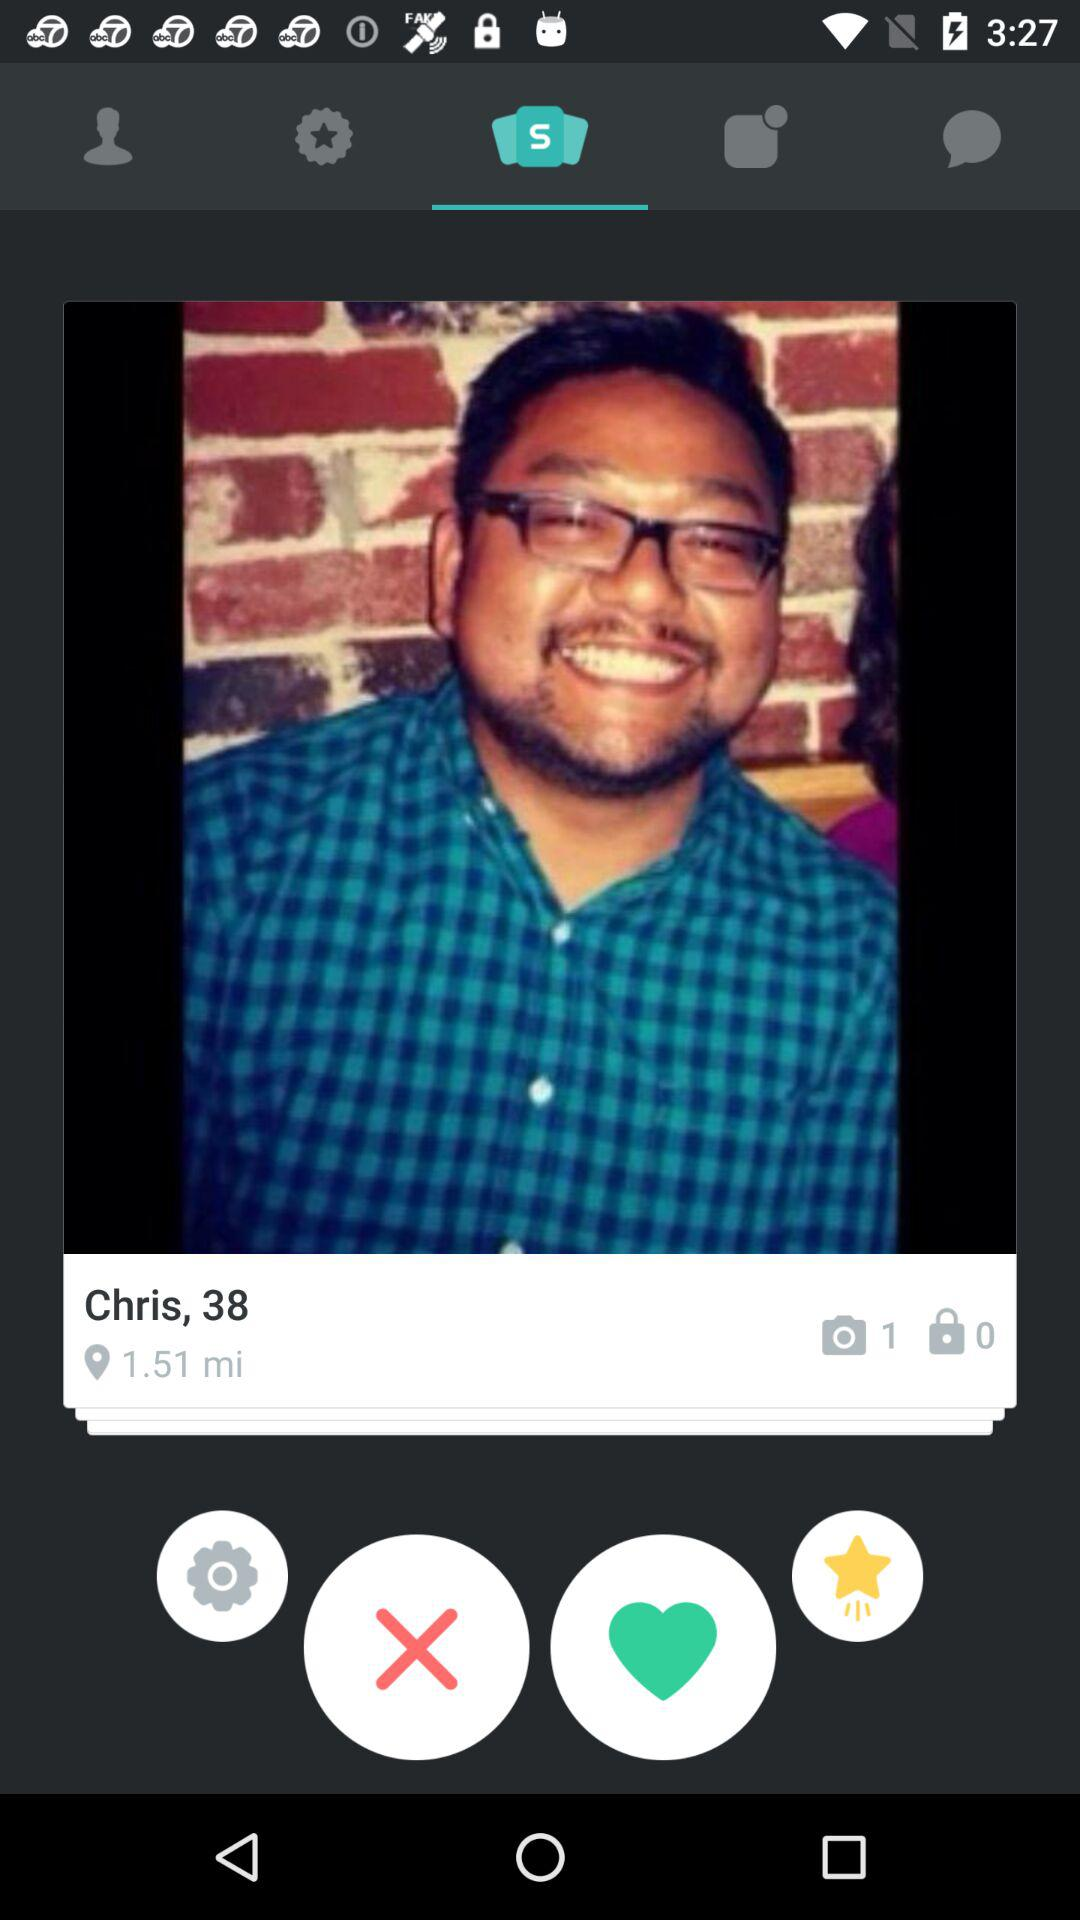What is the age of the user? The age of the user is 38. 